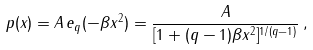Convert formula to latex. <formula><loc_0><loc_0><loc_500><loc_500>p ( x ) = A \, e _ { q } ( - \beta x ^ { 2 } ) = \frac { A } { [ 1 + ( q - 1 ) \beta x ^ { 2 } ] ^ { 1 / ( q - 1 ) } } \, ,</formula> 